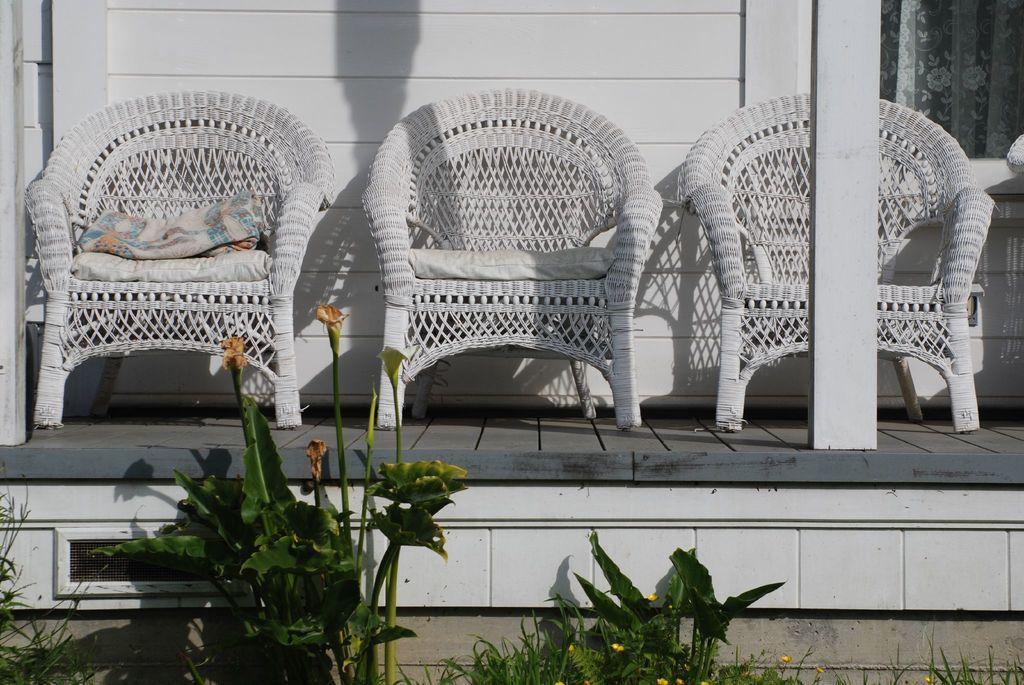How would you summarize this image in a sentence or two? In the image there are chairs. There are cushions on it. To the below there are plants. In the background there is wall and curtain. 